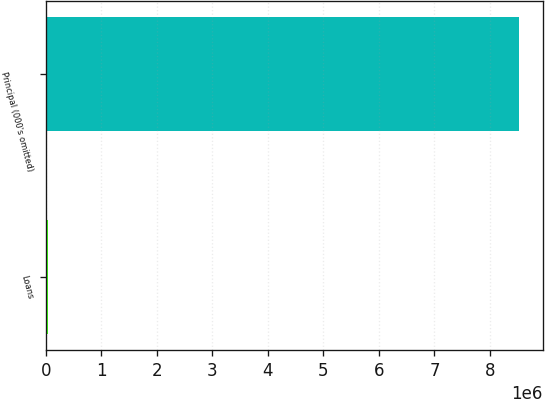<chart> <loc_0><loc_0><loc_500><loc_500><bar_chart><fcel>Loans<fcel>Principal (000's omitted)<nl><fcel>42994<fcel>8.5286e+06<nl></chart> 